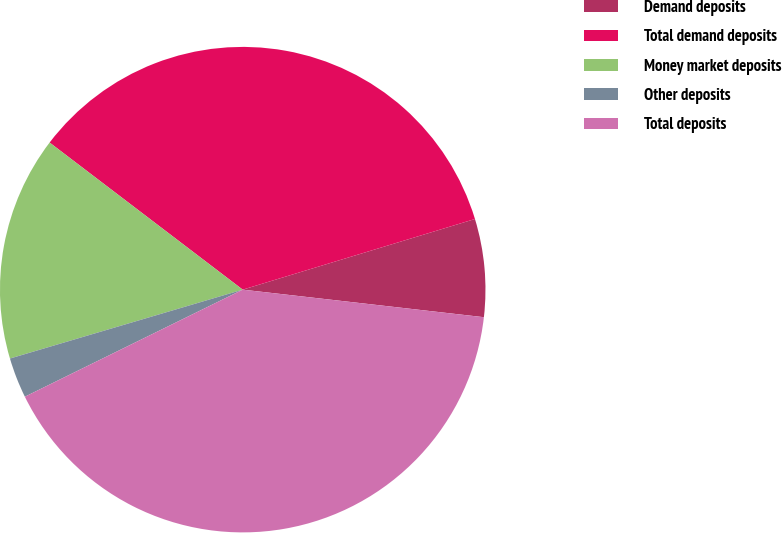Convert chart to OTSL. <chart><loc_0><loc_0><loc_500><loc_500><pie_chart><fcel>Demand deposits<fcel>Total demand deposits<fcel>Money market deposits<fcel>Other deposits<fcel>Total deposits<nl><fcel>6.51%<fcel>34.94%<fcel>14.94%<fcel>2.69%<fcel>40.92%<nl></chart> 